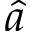<formula> <loc_0><loc_0><loc_500><loc_500>\hat { a }</formula> 